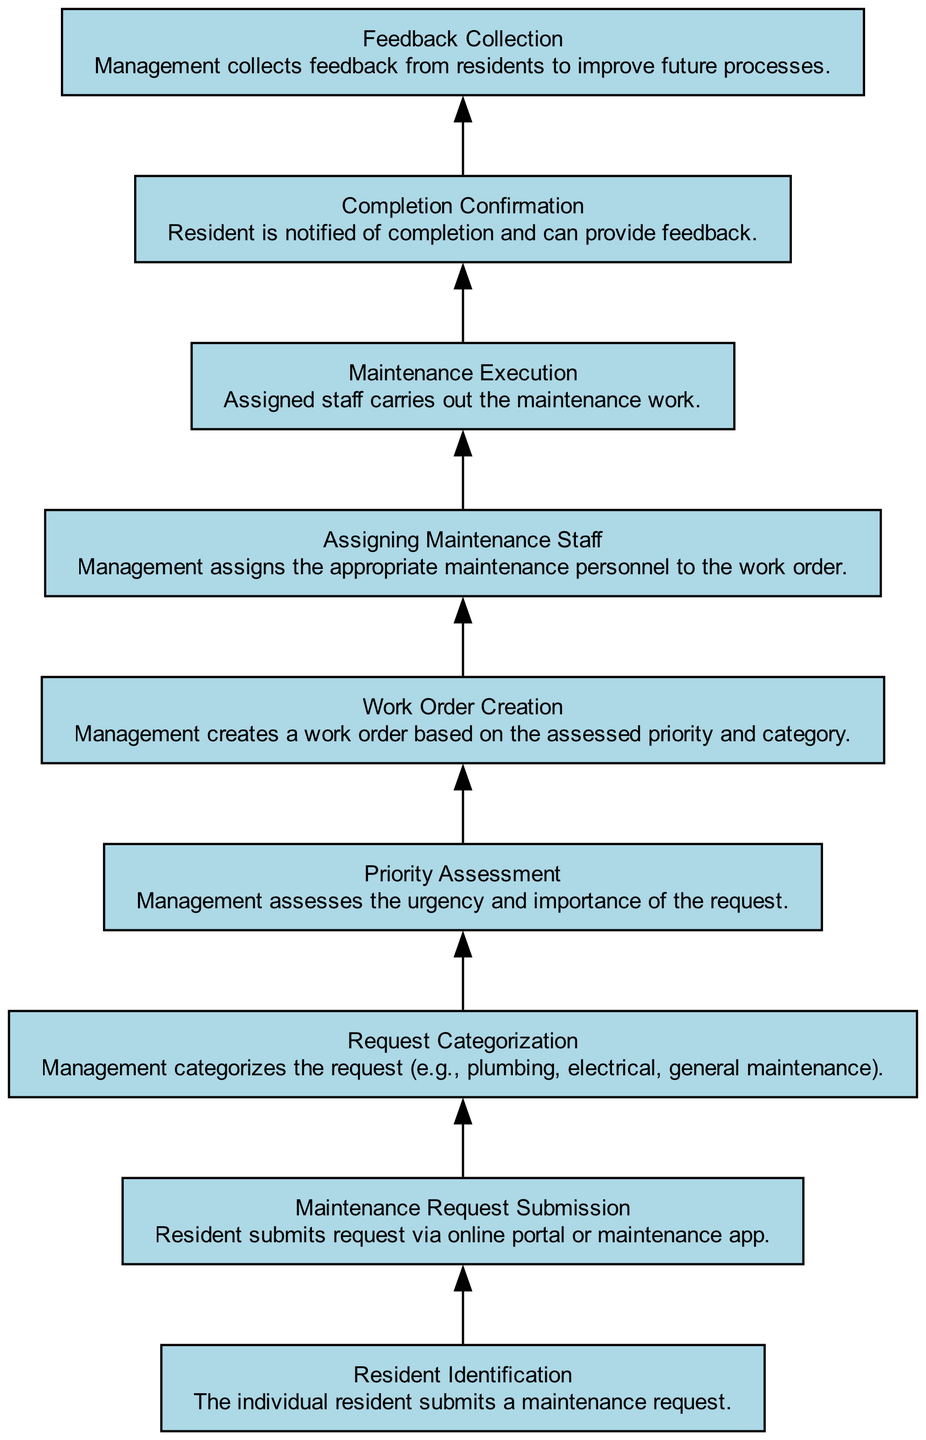What is the first step in the maintenance request flow? The diagram starts with "Resident Identification," where the individual resident submits a maintenance request.
Answer: Resident Identification What action do residents take to submit their request? According to the diagram, residents submit their request via an online portal or a maintenance app.
Answer: Maintenance Request Submission How many total steps are there in the maintenance request flow? By counting all the unique steps represented in the diagram, there are 9 distinct steps listed.
Answer: 9 What is the purpose of the "Request Categorization" step? This step involves management categorizing the maintenance request into specific types such as plumbing, electrical, or general maintenance.
Answer: Categorizes requests Which step follows the "Priority Assessment" in the flow? After the "Priority Assessment," the next step is "Work Order Creation," which is the step where management creates a work order.
Answer: Work Order Creation What happens after the "Maintenance Execution"? The subsequent step after "Maintenance Execution" is "Completion Confirmation," where residents are notified of the work's completion.
Answer: Completion Confirmation What is the last step in the maintenance request process? The last step in the maintenance request flow outlined in the diagram is "Feedback Collection," where management gathers residents' feedback.
Answer: Feedback Collection How does the flow ensure resident feedback is collected? The flow incorporates a separate step called "Feedback Collection" which specifically states that management collects feedback from residents.
Answer: Management collects feedback Which step involves assigning maintenance staff? The step that involves assigning personnel to conduct the maintenance work is labeled as "Assigning Maintenance Staff."
Answer: Assigning Maintenance Staff 